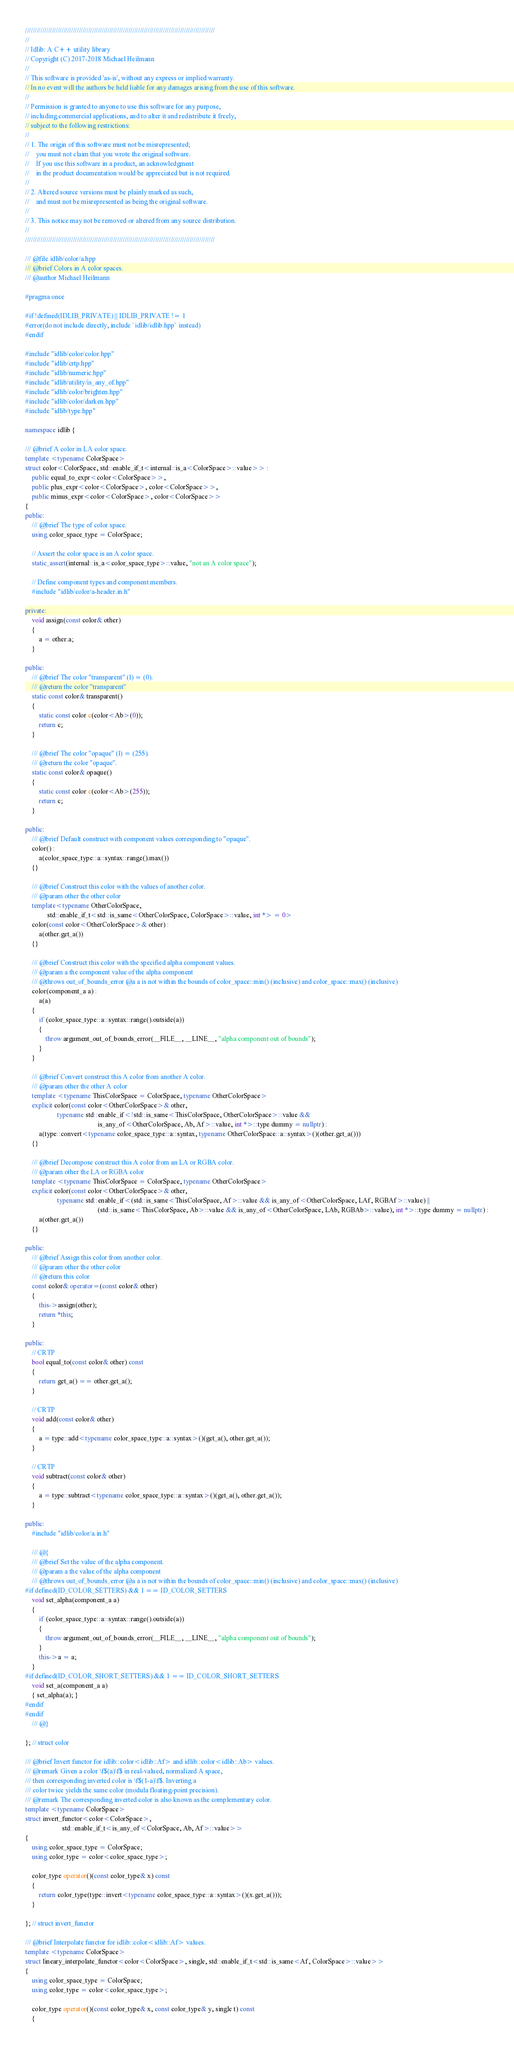<code> <loc_0><loc_0><loc_500><loc_500><_C++_>///////////////////////////////////////////////////////////////////////////////////////////////////
//
// Idlib: A C++ utility library
// Copyright (C) 2017-2018 Michael Heilmann
//
// This software is provided 'as-is', without any express or implied warranty.
// In no event will the authors be held liable for any damages arising from the use of this software.
//
// Permission is granted to anyone to use this software for any purpose,
// including commercial applications, and to alter it and redistribute it freely,
// subject to the following restrictions:
//
// 1. The origin of this software must not be misrepresented;
//    you must not claim that you wrote the original software.
//    If you use this software in a product, an acknowledgment
//    in the product documentation would be appreciated but is not required.
//
// 2. Altered source versions must be plainly marked as such,
//    and must not be misrepresented as being the original software.
//
// 3. This notice may not be removed or altered from any source distribution.
//
///////////////////////////////////////////////////////////////////////////////////////////////////

/// @file idlib/color/a.hpp
/// @brief Colors in A color spaces.
/// @author Michael Heilmann

#pragma once

#if !defined(IDLIB_PRIVATE) || IDLIB_PRIVATE != 1
#error(do not include directly, include `idlib/idlib.hpp` instead)
#endif

#include "idlib/color/color.hpp"
#include "idlib/crtp.hpp"
#include "idlib/numeric.hpp"
#include "idlib/utility/is_any_of.hpp"
#include "idlib/color/brighten.hpp"
#include "idlib/color/darken.hpp"
#include "idlib/type.hpp"

namespace idlib {

/// @brief A color in LA color space.
template <typename ColorSpace>
struct color<ColorSpace, std::enable_if_t<internal::is_a<ColorSpace>::value>> :
    public equal_to_expr<color<ColorSpace>>,
    public plus_expr<color<ColorSpace>, color<ColorSpace>>,
    public minus_expr<color<ColorSpace>, color<ColorSpace>>
{
public:
    /// @brief The type of color space.
    using color_space_type = ColorSpace;

    // Assert the color space is an A color space.
    static_assert(internal::is_a<color_space_type>::value, "not an A color space");

    // Define component types and component members.
    #include "idlib/color/a-header.in.h"

private:
    void assign(const color& other)
    {
        a = other.a;
    }

public:
    /// @brief The color "transparent" (l) = (0).
    /// @return the color "transparent"
    static const color& transparent()
    {
        static const color c(color<Ab>(0));
        return c;
    }

    /// @brief The color "opaque" (l) = (255).
    /// @return the color "opaque".
    static const color& opaque()
    {
        static const color c(color<Ab>(255));
        return c;
    }

public:
    /// @brief Default construct with component values corresponding to "opaque".
    color() :
        a(color_space_type::a::syntax::range().max())
    {}

    /// @brief Construct this color with the values of another color.
    /// @param other the other color
    template<typename OtherColorSpace,
             std::enable_if_t<std::is_same<OtherColorSpace, ColorSpace>::value, int *> = 0>
    color(const color<OtherColorSpace>& other) :
        a(other.get_a())
    {}

    /// @brief Construct this color with the specified alpha component values.
    /// @param a the component value of the alpha component
    /// @throws out_of_bounds_error @a a is not within the bounds of color_space::min() (inclusive) and color_space::max() (inclusive)
    color(component_a a) :
        a(a)
    {
        if (color_space_type::a::syntax::range().outside(a))
        {
            throw argument_out_of_bounds_error(__FILE__, __LINE__, "alpha component out of bounds");
        }
    }

    /// @brief Convert construct this A color from another A color.
    /// @param other the other A color
    template <typename ThisColorSpace = ColorSpace, typename OtherColorSpace>
    explicit color(const color<OtherColorSpace>& other,
                   typename std::enable_if<!std::is_same<ThisColorSpace, OtherColorSpace>::value &&
                                           is_any_of<OtherColorSpace, Ab, Af>::value, int *>::type dummy = nullptr) :
        a(type::convert<typename color_space_type::a::syntax, typename OtherColorSpace::a::syntax>()(other.get_a()))
    {}

    /// @brief Decompose construct this A color from an LA or RGBA color.
    /// @param other the LA or RGBA color
    template <typename ThisColorSpace = ColorSpace, typename OtherColorSpace>
    explicit color(const color<OtherColorSpace>& other,
                   typename std::enable_if<(std::is_same<ThisColorSpace, Af>::value && is_any_of<OtherColorSpace, LAf, RGBAf>::value) ||
                                           (std::is_same<ThisColorSpace, Ab>::value && is_any_of<OtherColorSpace, LAb, RGBAb>::value), int *>::type dummy = nullptr) :
        a(other.get_a())
    {}

public:
    /// @brief Assign this color from another color.
    /// @param other the other color
    /// @return this color
    const color& operator=(const color& other)
    {
        this->assign(other);
        return *this;
    }

public:
    // CRTP
    bool equal_to(const color& other) const
    {
        return get_a() == other.get_a();
    }

    // CRTP
    void add(const color& other)
    {
        a = type::add<typename color_space_type::a::syntax>()(get_a(), other.get_a());
    }

    // CRTP
    void subtract(const color& other)
    {
        a = type::subtract<typename color_space_type::a::syntax>()(get_a(), other.get_a());
    }

public:
    #include "idlib/color/a.in.h"

    /// @{
    /// @brief Set the value of the alpha component.
    /// @param a the value of the alpha component
    /// @throws out_of_bounds_error @a a is not within the bounds of color_space::min() (inclusive) and color_space::max() (inclusive)
#if defined(ID_COLOR_SETTERS) && 1 == ID_COLOR_SETTERS
    void set_alpha(component_a a)
    {
        if (color_space_type::a::syntax::range().outside(a))
        {
            throw argument_out_of_bounds_error(__FILE__, __LINE__, "alpha component out of bounds");
        }
        this->a = a;
    }
#if defined(ID_COLOR_SHORT_SETTERS) && 1 == ID_COLOR_SHORT_SETTERS
    void set_a(component_a a)
    { set_alpha(a); }
#endif
#endif
    /// @}

}; // struct color

/// @brief Invert functor for idlib::color<idlib::Af> and idlib::color<idlib::Ab> values.
/// @remark Given a color \f$(a)\f$ in real-valued, normalized A space,
/// then corresponding inverted color is \f$(1-a)\f$. Inverting a
/// color twice yields the same color (modula floating-point precision).
/// @remark The corresponding inverted color is also known as the complementary color.
template <typename ColorSpace>
struct invert_functor<color<ColorSpace>,
                      std::enable_if_t<is_any_of<ColorSpace, Ab, Af>::value>>
{
    using color_space_type = ColorSpace;
    using color_type = color<color_space_type>;

    color_type operator()(const color_type& x) const
    {
        return color_type(type::invert<typename color_space_type::a::syntax>()(x.get_a()));
    }

}; // struct invert_functor

/// @brief Interpolate functor for idlib::color<idlib::Af> values.
template <typename ColorSpace>
struct lineary_interpolate_functor<color<ColorSpace>, single, std::enable_if_t<std::is_same<Af, ColorSpace>::value>>
{
    using color_space_type = ColorSpace;
    using color_type = color<color_space_type>;

    color_type operator()(const color_type& x, const color_type& y, single t) const
    {</code> 